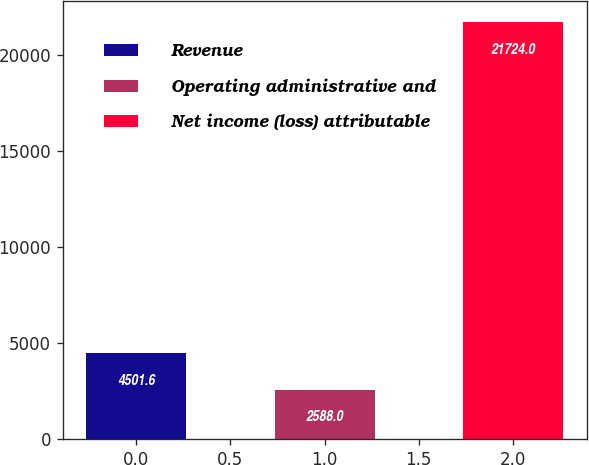Convert chart. <chart><loc_0><loc_0><loc_500><loc_500><bar_chart><fcel>Revenue<fcel>Operating administrative and<fcel>Net income (loss) attributable<nl><fcel>4501.6<fcel>2588<fcel>21724<nl></chart> 